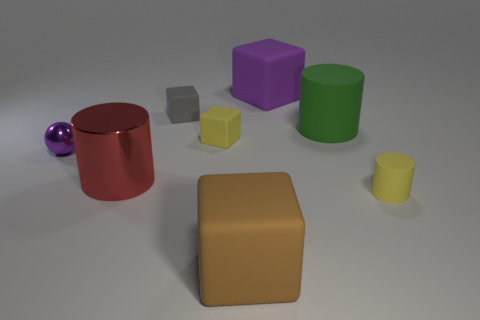Subtract 1 blocks. How many blocks are left? 3 Add 1 purple matte blocks. How many objects exist? 9 Subtract all balls. How many objects are left? 7 Add 1 large red matte spheres. How many large red matte spheres exist? 1 Subtract 0 cyan cylinders. How many objects are left? 8 Subtract all metal objects. Subtract all large rubber cylinders. How many objects are left? 5 Add 1 gray blocks. How many gray blocks are left? 2 